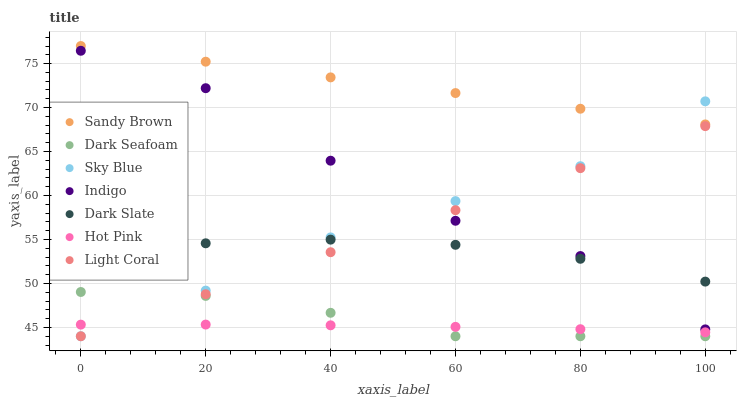Does Hot Pink have the minimum area under the curve?
Answer yes or no. Yes. Does Sandy Brown have the maximum area under the curve?
Answer yes or no. Yes. Does Light Coral have the minimum area under the curve?
Answer yes or no. No. Does Light Coral have the maximum area under the curve?
Answer yes or no. No. Is Sandy Brown the smoothest?
Answer yes or no. Yes. Is Indigo the roughest?
Answer yes or no. Yes. Is Hot Pink the smoothest?
Answer yes or no. No. Is Hot Pink the roughest?
Answer yes or no. No. Does Light Coral have the lowest value?
Answer yes or no. Yes. Does Hot Pink have the lowest value?
Answer yes or no. No. Does Sandy Brown have the highest value?
Answer yes or no. Yes. Does Light Coral have the highest value?
Answer yes or no. No. Is Light Coral less than Sandy Brown?
Answer yes or no. Yes. Is Indigo greater than Hot Pink?
Answer yes or no. Yes. Does Sky Blue intersect Dark Slate?
Answer yes or no. Yes. Is Sky Blue less than Dark Slate?
Answer yes or no. No. Is Sky Blue greater than Dark Slate?
Answer yes or no. No. Does Light Coral intersect Sandy Brown?
Answer yes or no. No. 